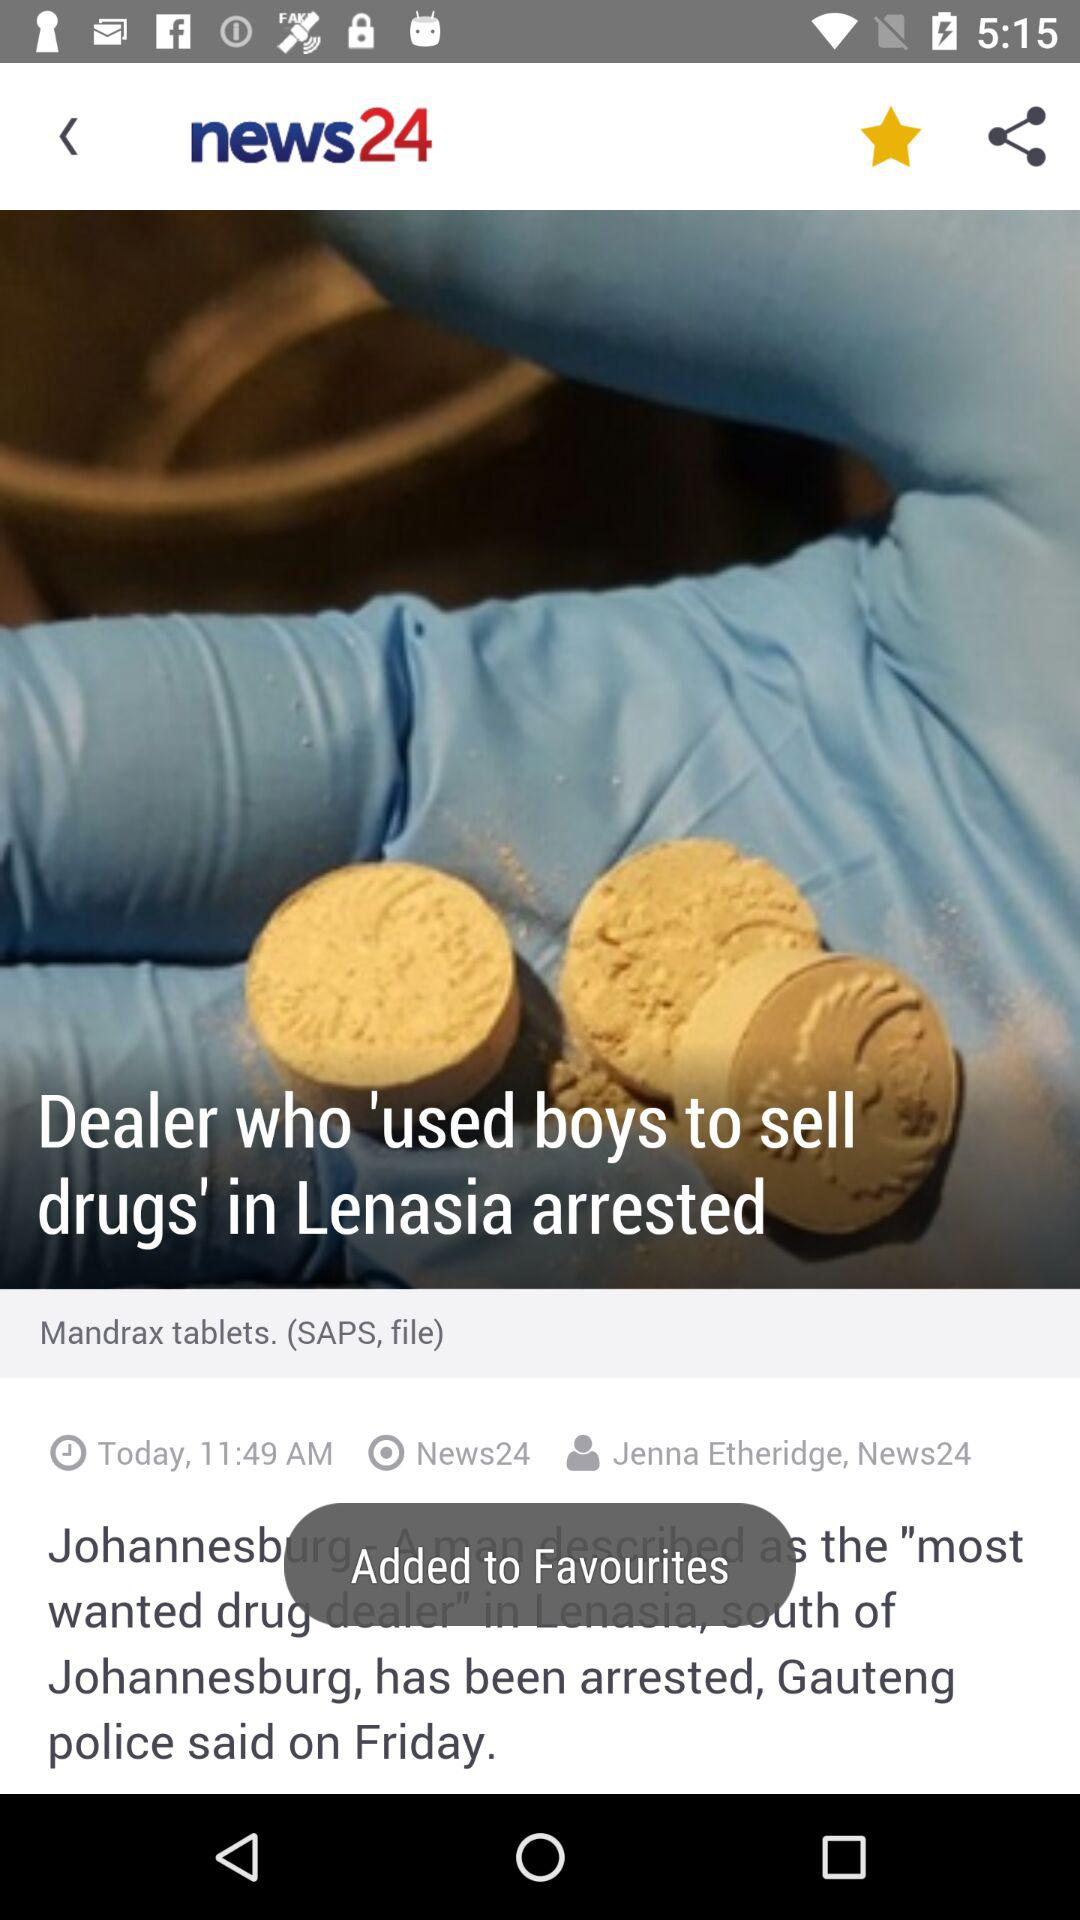What is the app title? The app title is "news24". 